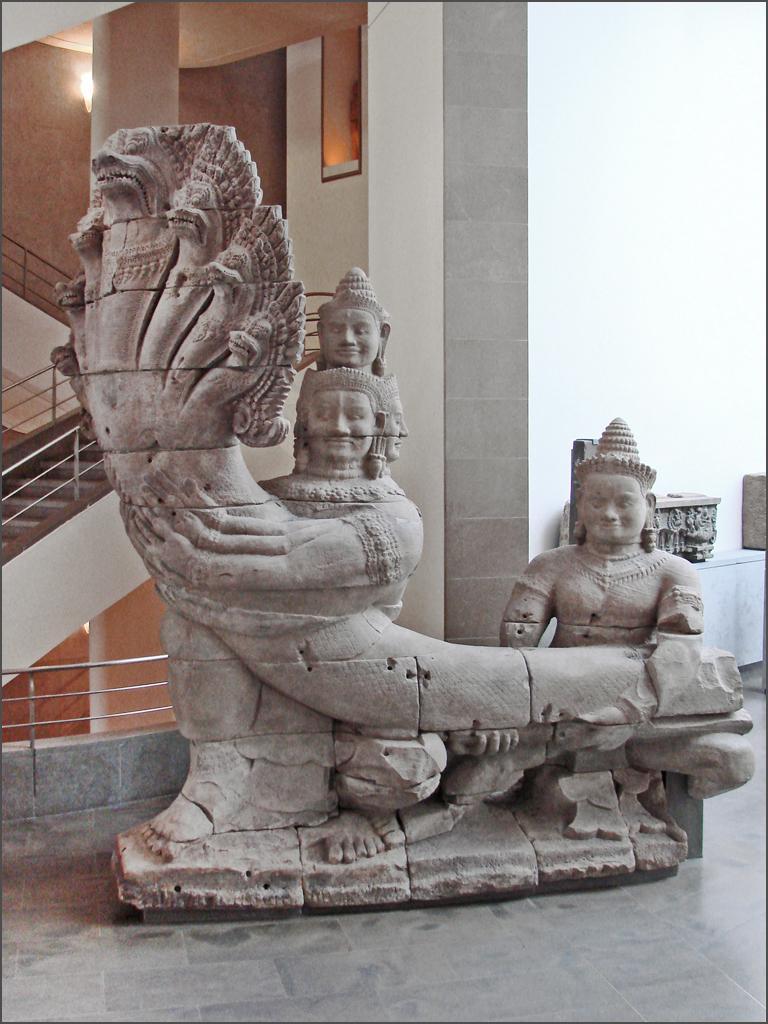In one or two sentences, can you explain what this image depicts? In the image there is a sculpture and behind the sculpture there are stairs in a building. 